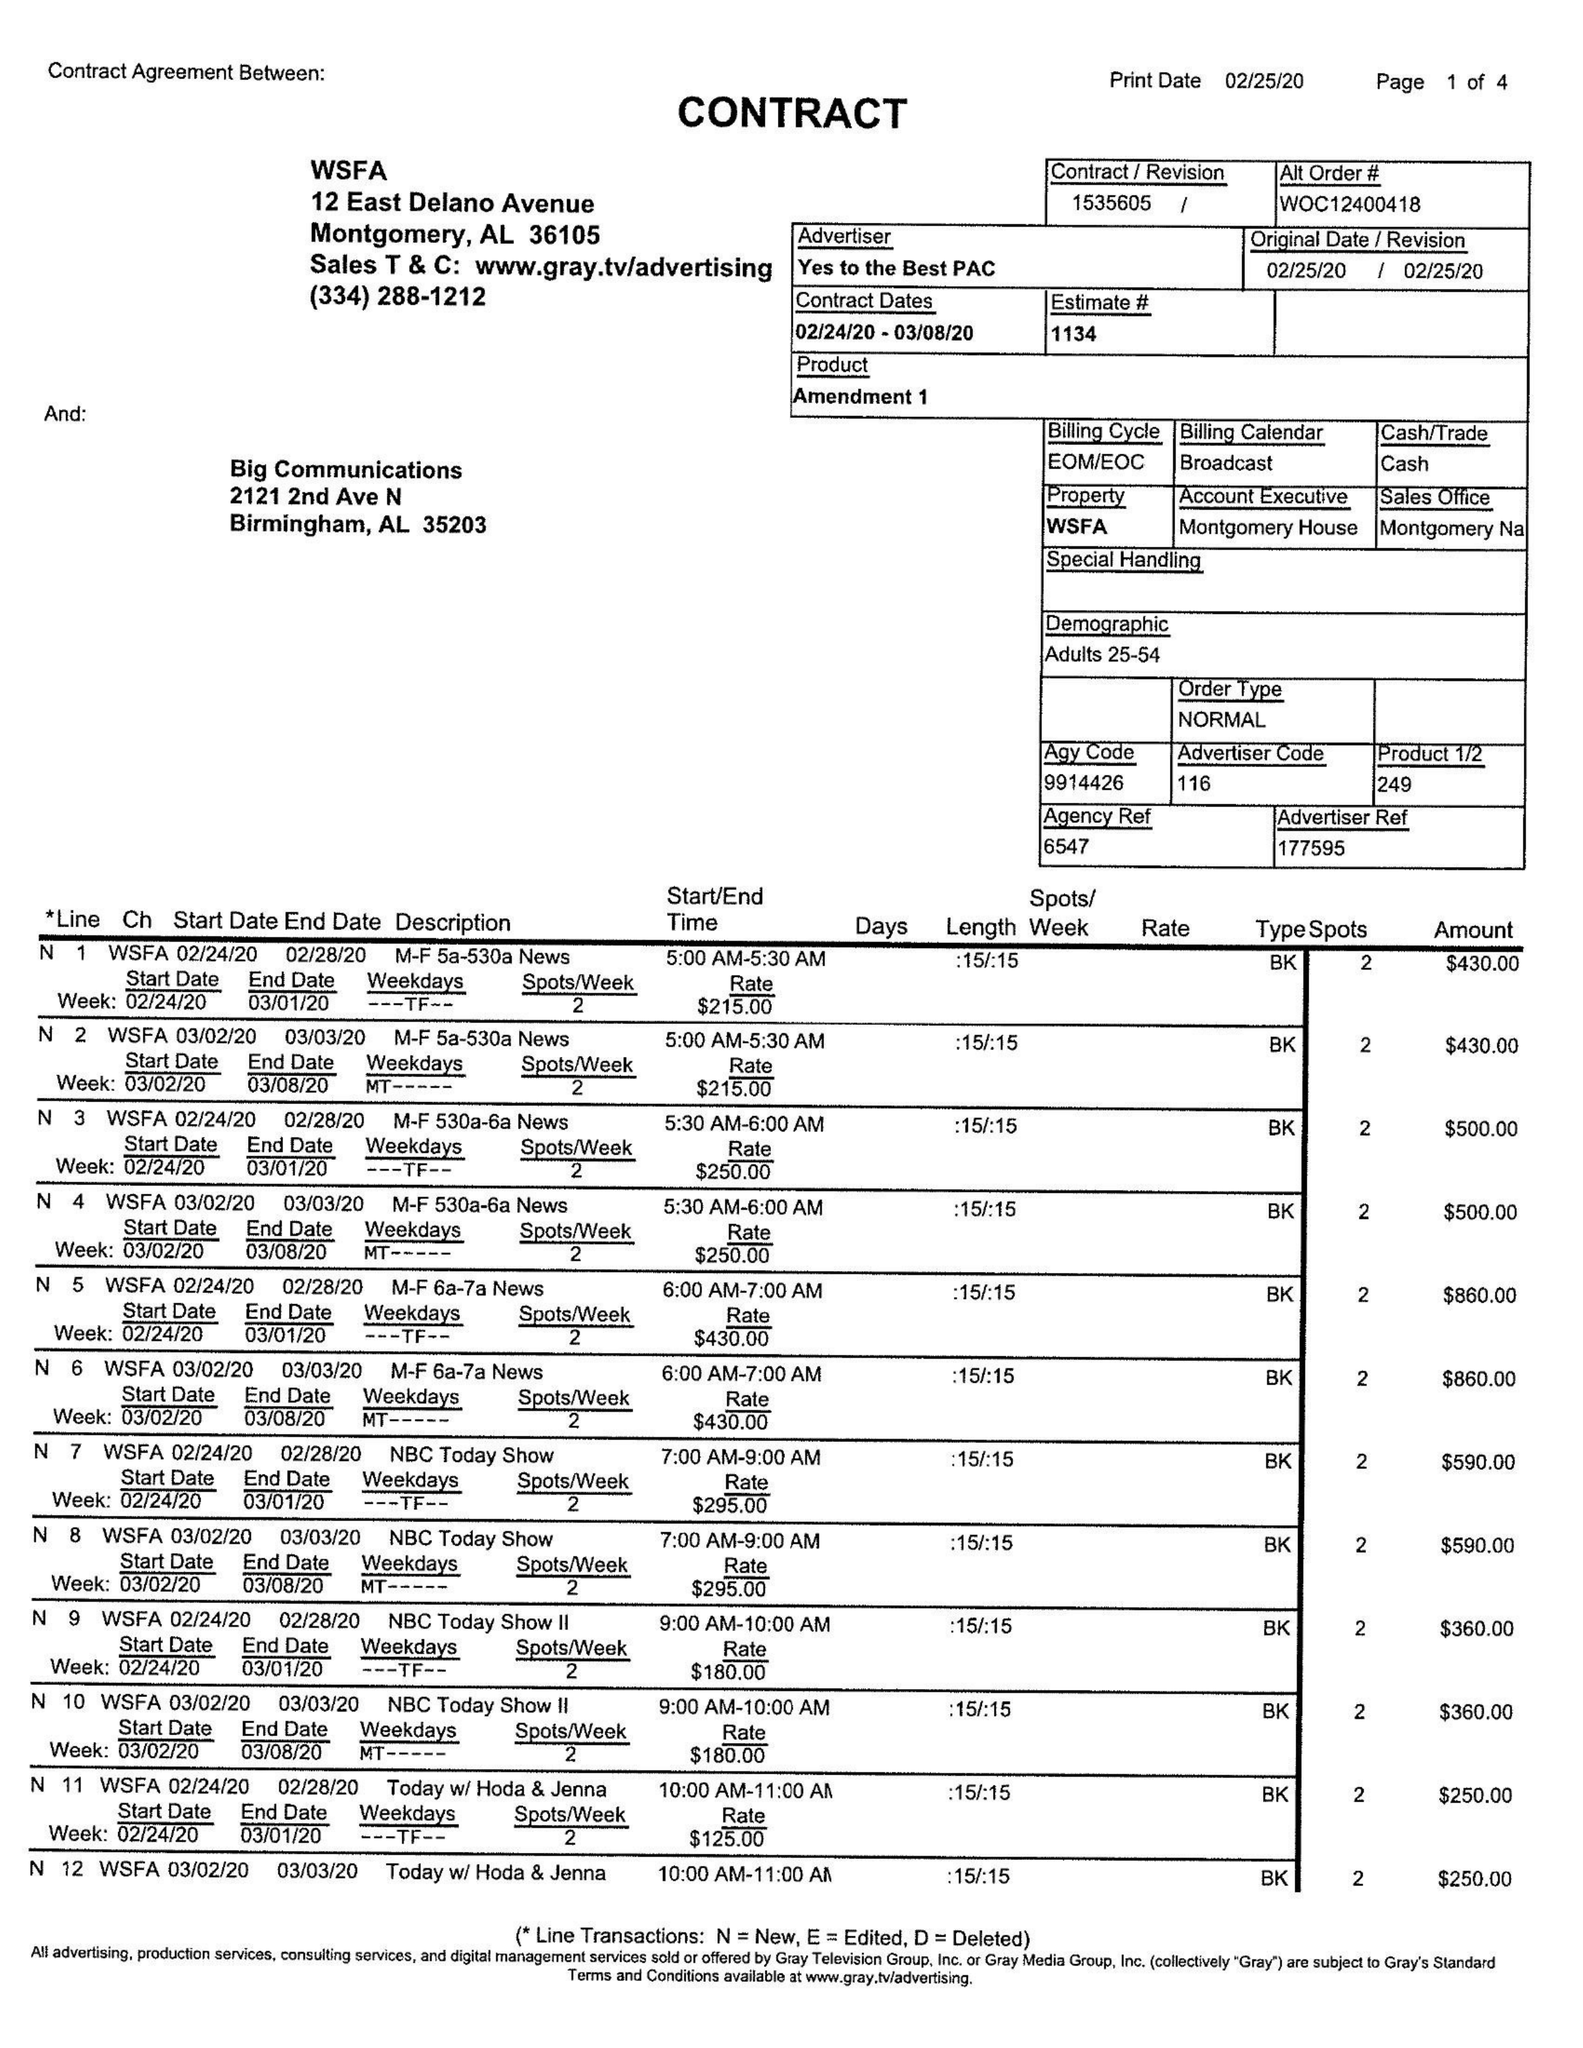What is the value for the advertiser?
Answer the question using a single word or phrase. YES TO THE BEST PAC 